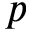<formula> <loc_0><loc_0><loc_500><loc_500>p</formula> 